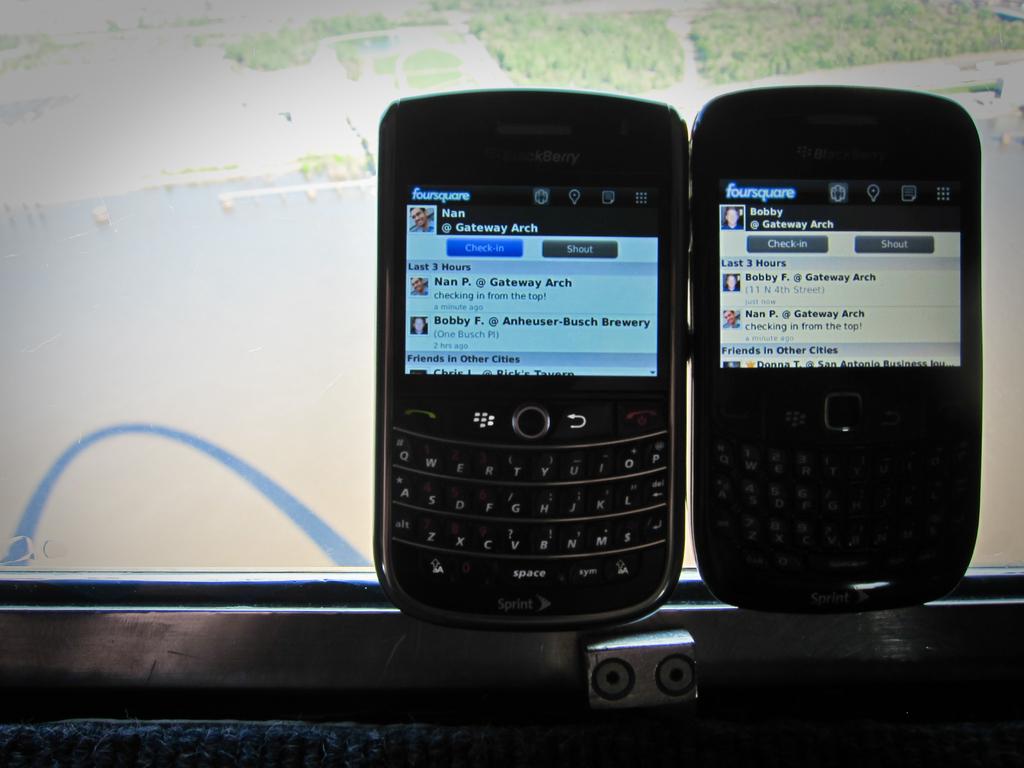Who's name is on the right phone?
Your answer should be compact. Bobby. 